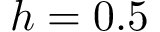<formula> <loc_0><loc_0><loc_500><loc_500>h = 0 . 5</formula> 